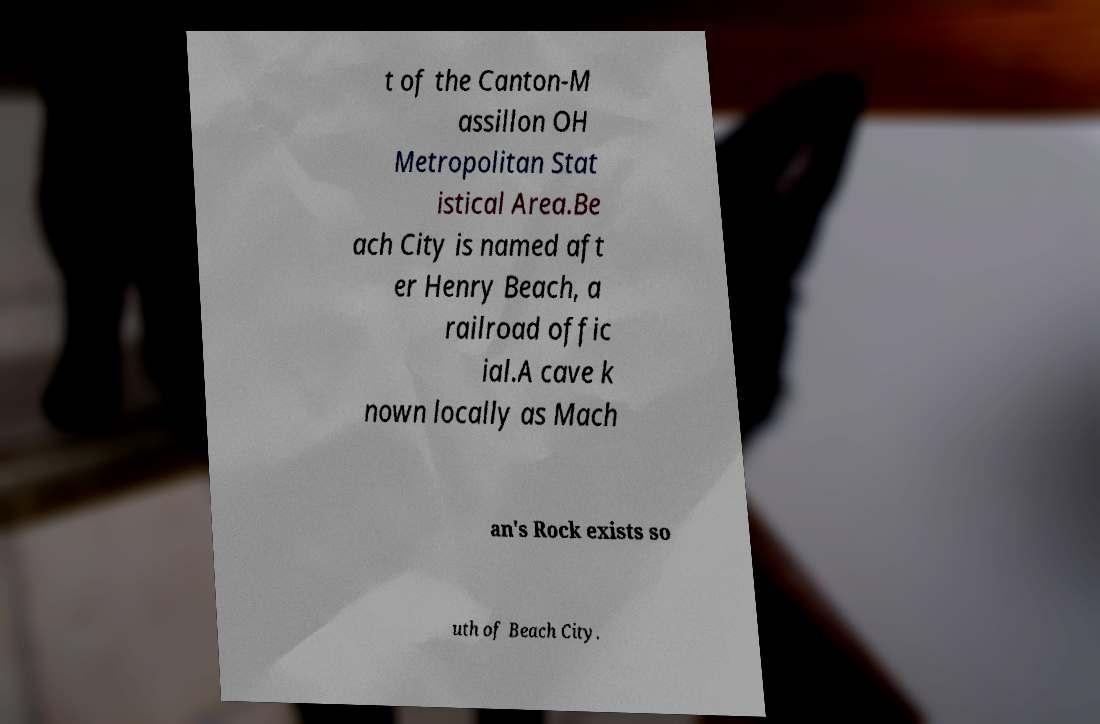Please read and relay the text visible in this image. What does it say? t of the Canton-M assillon OH Metropolitan Stat istical Area.Be ach City is named aft er Henry Beach, a railroad offic ial.A cave k nown locally as Mach an's Rock exists so uth of Beach City. 